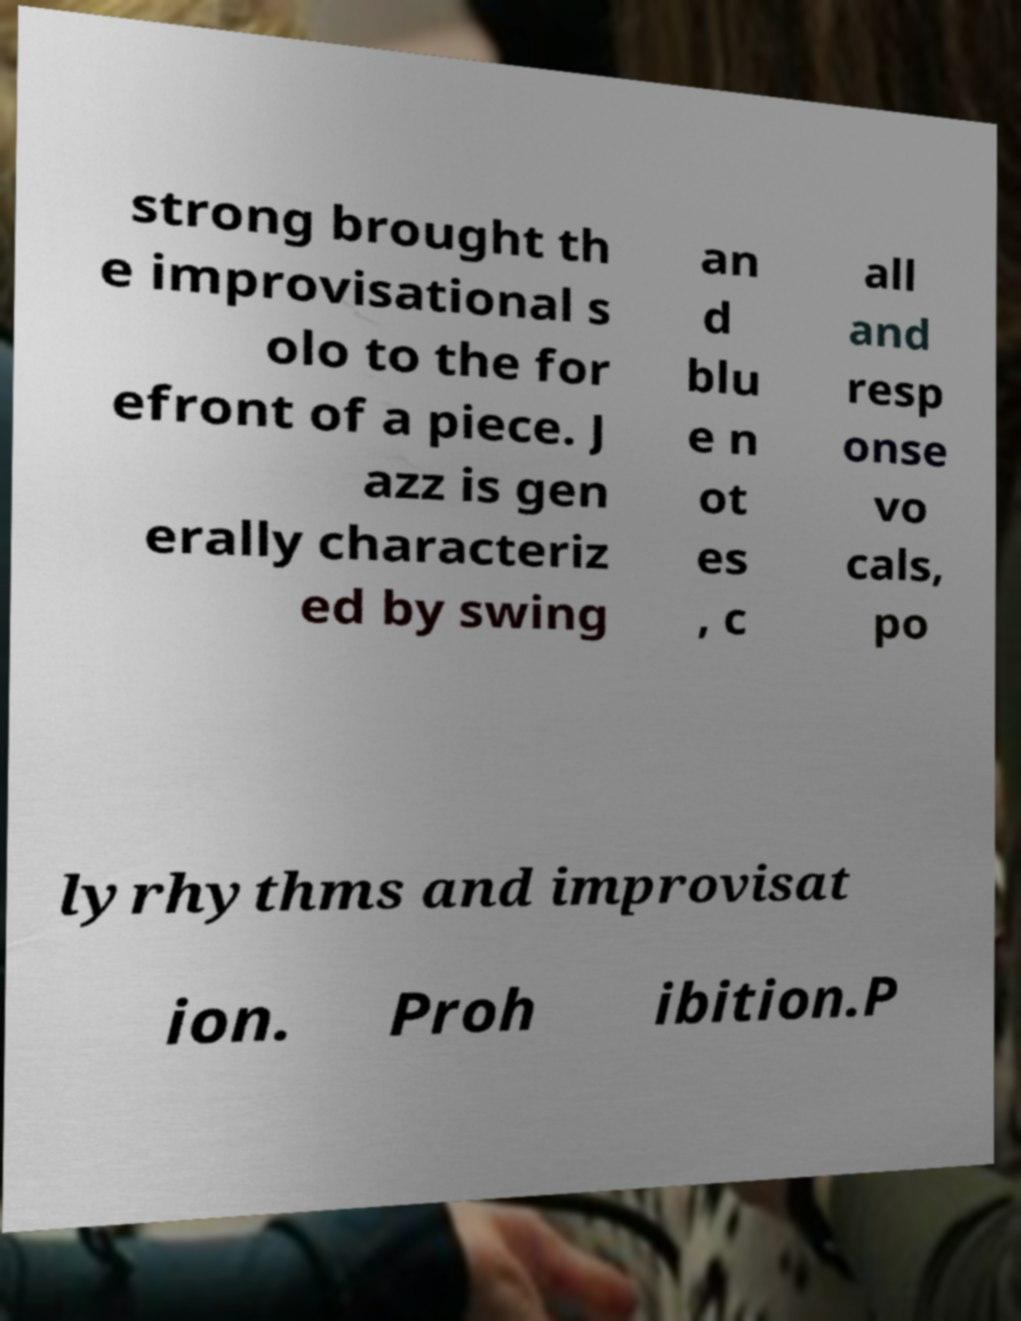Please read and relay the text visible in this image. What does it say? strong brought th e improvisational s olo to the for efront of a piece. J azz is gen erally characteriz ed by swing an d blu e n ot es , c all and resp onse vo cals, po lyrhythms and improvisat ion. Proh ibition.P 